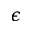<formula> <loc_0><loc_0><loc_500><loc_500>\epsilon</formula> 